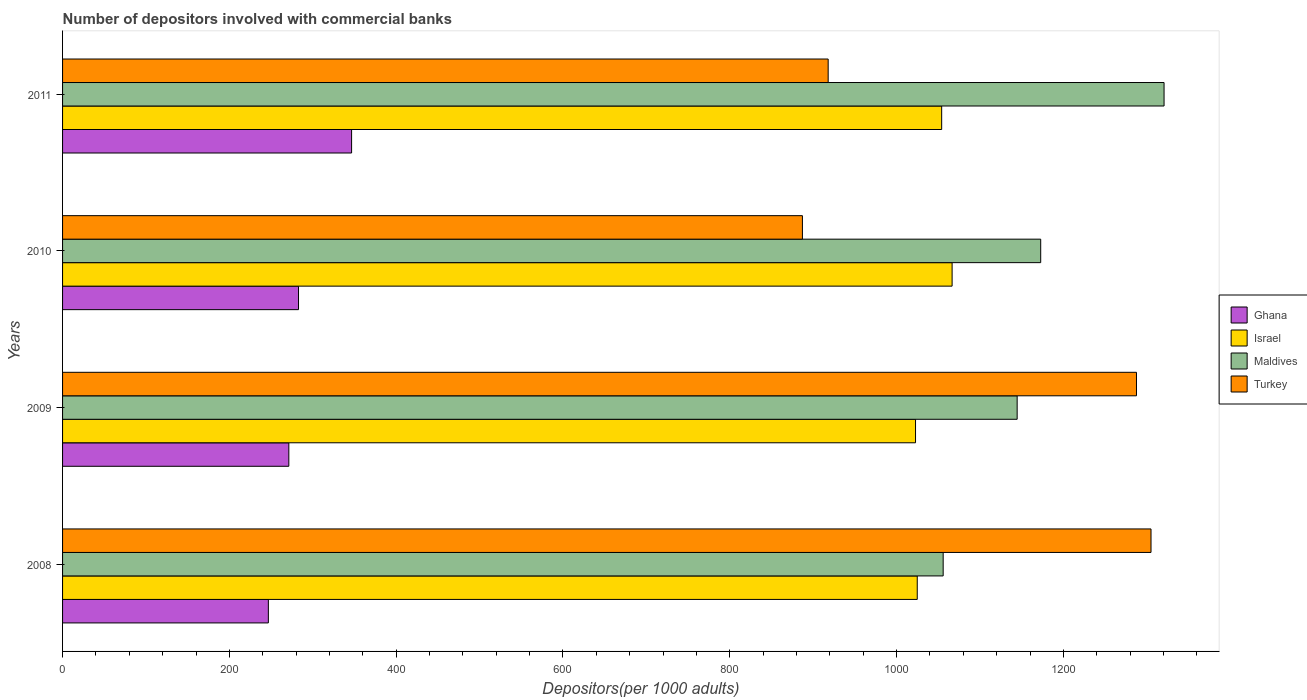How many different coloured bars are there?
Give a very brief answer. 4. Are the number of bars per tick equal to the number of legend labels?
Your answer should be very brief. Yes. Are the number of bars on each tick of the Y-axis equal?
Offer a terse response. Yes. What is the number of depositors involved with commercial banks in Turkey in 2011?
Offer a terse response. 917.97. Across all years, what is the maximum number of depositors involved with commercial banks in Maldives?
Make the answer very short. 1320.69. Across all years, what is the minimum number of depositors involved with commercial banks in Maldives?
Your answer should be compact. 1055.84. In which year was the number of depositors involved with commercial banks in Maldives maximum?
Your response must be concise. 2011. What is the total number of depositors involved with commercial banks in Ghana in the graph?
Give a very brief answer. 1147.49. What is the difference between the number of depositors involved with commercial banks in Ghana in 2008 and that in 2010?
Ensure brevity in your answer.  -36.17. What is the difference between the number of depositors involved with commercial banks in Maldives in 2010 and the number of depositors involved with commercial banks in Ghana in 2011?
Make the answer very short. 826.24. What is the average number of depositors involved with commercial banks in Maldives per year?
Give a very brief answer. 1173.47. In the year 2008, what is the difference between the number of depositors involved with commercial banks in Ghana and number of depositors involved with commercial banks in Maldives?
Offer a terse response. -809.09. In how many years, is the number of depositors involved with commercial banks in Ghana greater than 1080 ?
Offer a terse response. 0. What is the ratio of the number of depositors involved with commercial banks in Israel in 2008 to that in 2009?
Make the answer very short. 1. Is the number of depositors involved with commercial banks in Turkey in 2008 less than that in 2010?
Give a very brief answer. No. What is the difference between the highest and the second highest number of depositors involved with commercial banks in Ghana?
Your response must be concise. 63.63. What is the difference between the highest and the lowest number of depositors involved with commercial banks in Israel?
Ensure brevity in your answer.  43.86. Is it the case that in every year, the sum of the number of depositors involved with commercial banks in Maldives and number of depositors involved with commercial banks in Ghana is greater than the sum of number of depositors involved with commercial banks in Turkey and number of depositors involved with commercial banks in Israel?
Provide a short and direct response. No. What does the 4th bar from the top in 2011 represents?
Your response must be concise. Ghana. What does the 4th bar from the bottom in 2009 represents?
Provide a short and direct response. Turkey. How many bars are there?
Provide a short and direct response. 16. Are all the bars in the graph horizontal?
Your answer should be very brief. Yes. What is the difference between two consecutive major ticks on the X-axis?
Offer a very short reply. 200. Does the graph contain any zero values?
Provide a short and direct response. No. Does the graph contain grids?
Offer a very short reply. No. Where does the legend appear in the graph?
Keep it short and to the point. Center right. How are the legend labels stacked?
Offer a terse response. Vertical. What is the title of the graph?
Provide a succinct answer. Number of depositors involved with commercial banks. Does "Bhutan" appear as one of the legend labels in the graph?
Ensure brevity in your answer.  No. What is the label or title of the X-axis?
Offer a terse response. Depositors(per 1000 adults). What is the Depositors(per 1000 adults) in Ghana in 2008?
Make the answer very short. 246.75. What is the Depositors(per 1000 adults) of Israel in 2008?
Offer a terse response. 1024.76. What is the Depositors(per 1000 adults) in Maldives in 2008?
Keep it short and to the point. 1055.84. What is the Depositors(per 1000 adults) in Turkey in 2008?
Provide a short and direct response. 1305.04. What is the Depositors(per 1000 adults) in Ghana in 2009?
Ensure brevity in your answer.  271.28. What is the Depositors(per 1000 adults) of Israel in 2009?
Ensure brevity in your answer.  1022.7. What is the Depositors(per 1000 adults) in Maldives in 2009?
Make the answer very short. 1144.57. What is the Depositors(per 1000 adults) in Turkey in 2009?
Your answer should be compact. 1287.64. What is the Depositors(per 1000 adults) in Ghana in 2010?
Keep it short and to the point. 282.91. What is the Depositors(per 1000 adults) of Israel in 2010?
Your answer should be compact. 1066.56. What is the Depositors(per 1000 adults) in Maldives in 2010?
Provide a short and direct response. 1172.79. What is the Depositors(per 1000 adults) in Turkey in 2010?
Make the answer very short. 887.08. What is the Depositors(per 1000 adults) in Ghana in 2011?
Provide a succinct answer. 346.55. What is the Depositors(per 1000 adults) in Israel in 2011?
Provide a short and direct response. 1054.06. What is the Depositors(per 1000 adults) in Maldives in 2011?
Provide a succinct answer. 1320.69. What is the Depositors(per 1000 adults) in Turkey in 2011?
Make the answer very short. 917.97. Across all years, what is the maximum Depositors(per 1000 adults) in Ghana?
Offer a terse response. 346.55. Across all years, what is the maximum Depositors(per 1000 adults) of Israel?
Your answer should be compact. 1066.56. Across all years, what is the maximum Depositors(per 1000 adults) of Maldives?
Your answer should be very brief. 1320.69. Across all years, what is the maximum Depositors(per 1000 adults) of Turkey?
Your answer should be compact. 1305.04. Across all years, what is the minimum Depositors(per 1000 adults) of Ghana?
Your answer should be very brief. 246.75. Across all years, what is the minimum Depositors(per 1000 adults) of Israel?
Keep it short and to the point. 1022.7. Across all years, what is the minimum Depositors(per 1000 adults) in Maldives?
Your answer should be very brief. 1055.84. Across all years, what is the minimum Depositors(per 1000 adults) of Turkey?
Keep it short and to the point. 887.08. What is the total Depositors(per 1000 adults) of Ghana in the graph?
Offer a terse response. 1147.49. What is the total Depositors(per 1000 adults) of Israel in the graph?
Offer a terse response. 4168.08. What is the total Depositors(per 1000 adults) in Maldives in the graph?
Offer a terse response. 4693.88. What is the total Depositors(per 1000 adults) in Turkey in the graph?
Give a very brief answer. 4397.73. What is the difference between the Depositors(per 1000 adults) of Ghana in 2008 and that in 2009?
Give a very brief answer. -24.54. What is the difference between the Depositors(per 1000 adults) in Israel in 2008 and that in 2009?
Offer a terse response. 2.06. What is the difference between the Depositors(per 1000 adults) of Maldives in 2008 and that in 2009?
Ensure brevity in your answer.  -88.73. What is the difference between the Depositors(per 1000 adults) of Turkey in 2008 and that in 2009?
Offer a terse response. 17.41. What is the difference between the Depositors(per 1000 adults) of Ghana in 2008 and that in 2010?
Keep it short and to the point. -36.17. What is the difference between the Depositors(per 1000 adults) in Israel in 2008 and that in 2010?
Provide a short and direct response. -41.8. What is the difference between the Depositors(per 1000 adults) in Maldives in 2008 and that in 2010?
Offer a terse response. -116.95. What is the difference between the Depositors(per 1000 adults) of Turkey in 2008 and that in 2010?
Make the answer very short. 417.96. What is the difference between the Depositors(per 1000 adults) in Ghana in 2008 and that in 2011?
Offer a terse response. -99.8. What is the difference between the Depositors(per 1000 adults) of Israel in 2008 and that in 2011?
Ensure brevity in your answer.  -29.3. What is the difference between the Depositors(per 1000 adults) in Maldives in 2008 and that in 2011?
Provide a succinct answer. -264.85. What is the difference between the Depositors(per 1000 adults) of Turkey in 2008 and that in 2011?
Provide a short and direct response. 387.08. What is the difference between the Depositors(per 1000 adults) in Ghana in 2009 and that in 2010?
Provide a short and direct response. -11.63. What is the difference between the Depositors(per 1000 adults) of Israel in 2009 and that in 2010?
Provide a succinct answer. -43.86. What is the difference between the Depositors(per 1000 adults) in Maldives in 2009 and that in 2010?
Give a very brief answer. -28.22. What is the difference between the Depositors(per 1000 adults) of Turkey in 2009 and that in 2010?
Make the answer very short. 400.55. What is the difference between the Depositors(per 1000 adults) in Ghana in 2009 and that in 2011?
Give a very brief answer. -75.26. What is the difference between the Depositors(per 1000 adults) of Israel in 2009 and that in 2011?
Provide a short and direct response. -31.36. What is the difference between the Depositors(per 1000 adults) of Maldives in 2009 and that in 2011?
Your answer should be compact. -176.13. What is the difference between the Depositors(per 1000 adults) in Turkey in 2009 and that in 2011?
Provide a short and direct response. 369.67. What is the difference between the Depositors(per 1000 adults) of Ghana in 2010 and that in 2011?
Keep it short and to the point. -63.63. What is the difference between the Depositors(per 1000 adults) of Israel in 2010 and that in 2011?
Offer a terse response. 12.5. What is the difference between the Depositors(per 1000 adults) of Maldives in 2010 and that in 2011?
Give a very brief answer. -147.91. What is the difference between the Depositors(per 1000 adults) in Turkey in 2010 and that in 2011?
Your answer should be very brief. -30.88. What is the difference between the Depositors(per 1000 adults) of Ghana in 2008 and the Depositors(per 1000 adults) of Israel in 2009?
Ensure brevity in your answer.  -775.95. What is the difference between the Depositors(per 1000 adults) of Ghana in 2008 and the Depositors(per 1000 adults) of Maldives in 2009?
Your answer should be very brief. -897.82. What is the difference between the Depositors(per 1000 adults) of Ghana in 2008 and the Depositors(per 1000 adults) of Turkey in 2009?
Ensure brevity in your answer.  -1040.89. What is the difference between the Depositors(per 1000 adults) in Israel in 2008 and the Depositors(per 1000 adults) in Maldives in 2009?
Ensure brevity in your answer.  -119.8. What is the difference between the Depositors(per 1000 adults) of Israel in 2008 and the Depositors(per 1000 adults) of Turkey in 2009?
Offer a very short reply. -262.87. What is the difference between the Depositors(per 1000 adults) in Maldives in 2008 and the Depositors(per 1000 adults) in Turkey in 2009?
Make the answer very short. -231.8. What is the difference between the Depositors(per 1000 adults) of Ghana in 2008 and the Depositors(per 1000 adults) of Israel in 2010?
Make the answer very short. -819.82. What is the difference between the Depositors(per 1000 adults) of Ghana in 2008 and the Depositors(per 1000 adults) of Maldives in 2010?
Give a very brief answer. -926.04. What is the difference between the Depositors(per 1000 adults) in Ghana in 2008 and the Depositors(per 1000 adults) in Turkey in 2010?
Your response must be concise. -640.34. What is the difference between the Depositors(per 1000 adults) of Israel in 2008 and the Depositors(per 1000 adults) of Maldives in 2010?
Give a very brief answer. -148.02. What is the difference between the Depositors(per 1000 adults) in Israel in 2008 and the Depositors(per 1000 adults) in Turkey in 2010?
Make the answer very short. 137.68. What is the difference between the Depositors(per 1000 adults) in Maldives in 2008 and the Depositors(per 1000 adults) in Turkey in 2010?
Provide a succinct answer. 168.76. What is the difference between the Depositors(per 1000 adults) in Ghana in 2008 and the Depositors(per 1000 adults) in Israel in 2011?
Your answer should be very brief. -807.31. What is the difference between the Depositors(per 1000 adults) in Ghana in 2008 and the Depositors(per 1000 adults) in Maldives in 2011?
Give a very brief answer. -1073.95. What is the difference between the Depositors(per 1000 adults) of Ghana in 2008 and the Depositors(per 1000 adults) of Turkey in 2011?
Offer a terse response. -671.22. What is the difference between the Depositors(per 1000 adults) in Israel in 2008 and the Depositors(per 1000 adults) in Maldives in 2011?
Provide a succinct answer. -295.93. What is the difference between the Depositors(per 1000 adults) in Israel in 2008 and the Depositors(per 1000 adults) in Turkey in 2011?
Your response must be concise. 106.79. What is the difference between the Depositors(per 1000 adults) of Maldives in 2008 and the Depositors(per 1000 adults) of Turkey in 2011?
Make the answer very short. 137.87. What is the difference between the Depositors(per 1000 adults) of Ghana in 2009 and the Depositors(per 1000 adults) of Israel in 2010?
Your answer should be compact. -795.28. What is the difference between the Depositors(per 1000 adults) in Ghana in 2009 and the Depositors(per 1000 adults) in Maldives in 2010?
Your response must be concise. -901.5. What is the difference between the Depositors(per 1000 adults) of Ghana in 2009 and the Depositors(per 1000 adults) of Turkey in 2010?
Make the answer very short. -615.8. What is the difference between the Depositors(per 1000 adults) in Israel in 2009 and the Depositors(per 1000 adults) in Maldives in 2010?
Provide a succinct answer. -150.09. What is the difference between the Depositors(per 1000 adults) of Israel in 2009 and the Depositors(per 1000 adults) of Turkey in 2010?
Offer a very short reply. 135.62. What is the difference between the Depositors(per 1000 adults) in Maldives in 2009 and the Depositors(per 1000 adults) in Turkey in 2010?
Your answer should be compact. 257.48. What is the difference between the Depositors(per 1000 adults) of Ghana in 2009 and the Depositors(per 1000 adults) of Israel in 2011?
Offer a terse response. -782.77. What is the difference between the Depositors(per 1000 adults) in Ghana in 2009 and the Depositors(per 1000 adults) in Maldives in 2011?
Your answer should be compact. -1049.41. What is the difference between the Depositors(per 1000 adults) of Ghana in 2009 and the Depositors(per 1000 adults) of Turkey in 2011?
Provide a short and direct response. -646.68. What is the difference between the Depositors(per 1000 adults) of Israel in 2009 and the Depositors(per 1000 adults) of Maldives in 2011?
Your answer should be very brief. -297.99. What is the difference between the Depositors(per 1000 adults) of Israel in 2009 and the Depositors(per 1000 adults) of Turkey in 2011?
Your answer should be compact. 104.73. What is the difference between the Depositors(per 1000 adults) in Maldives in 2009 and the Depositors(per 1000 adults) in Turkey in 2011?
Provide a succinct answer. 226.6. What is the difference between the Depositors(per 1000 adults) of Ghana in 2010 and the Depositors(per 1000 adults) of Israel in 2011?
Ensure brevity in your answer.  -771.15. What is the difference between the Depositors(per 1000 adults) of Ghana in 2010 and the Depositors(per 1000 adults) of Maldives in 2011?
Ensure brevity in your answer.  -1037.78. What is the difference between the Depositors(per 1000 adults) of Ghana in 2010 and the Depositors(per 1000 adults) of Turkey in 2011?
Provide a short and direct response. -635.05. What is the difference between the Depositors(per 1000 adults) of Israel in 2010 and the Depositors(per 1000 adults) of Maldives in 2011?
Provide a succinct answer. -254.13. What is the difference between the Depositors(per 1000 adults) of Israel in 2010 and the Depositors(per 1000 adults) of Turkey in 2011?
Provide a succinct answer. 148.59. What is the difference between the Depositors(per 1000 adults) in Maldives in 2010 and the Depositors(per 1000 adults) in Turkey in 2011?
Provide a succinct answer. 254.82. What is the average Depositors(per 1000 adults) of Ghana per year?
Your response must be concise. 286.87. What is the average Depositors(per 1000 adults) of Israel per year?
Your answer should be compact. 1042.02. What is the average Depositors(per 1000 adults) in Maldives per year?
Provide a short and direct response. 1173.47. What is the average Depositors(per 1000 adults) of Turkey per year?
Offer a very short reply. 1099.43. In the year 2008, what is the difference between the Depositors(per 1000 adults) in Ghana and Depositors(per 1000 adults) in Israel?
Ensure brevity in your answer.  -778.02. In the year 2008, what is the difference between the Depositors(per 1000 adults) in Ghana and Depositors(per 1000 adults) in Maldives?
Your answer should be very brief. -809.09. In the year 2008, what is the difference between the Depositors(per 1000 adults) in Ghana and Depositors(per 1000 adults) in Turkey?
Provide a short and direct response. -1058.3. In the year 2008, what is the difference between the Depositors(per 1000 adults) of Israel and Depositors(per 1000 adults) of Maldives?
Your answer should be compact. -31.08. In the year 2008, what is the difference between the Depositors(per 1000 adults) in Israel and Depositors(per 1000 adults) in Turkey?
Provide a short and direct response. -280.28. In the year 2008, what is the difference between the Depositors(per 1000 adults) of Maldives and Depositors(per 1000 adults) of Turkey?
Make the answer very short. -249.2. In the year 2009, what is the difference between the Depositors(per 1000 adults) in Ghana and Depositors(per 1000 adults) in Israel?
Offer a very short reply. -751.42. In the year 2009, what is the difference between the Depositors(per 1000 adults) in Ghana and Depositors(per 1000 adults) in Maldives?
Offer a terse response. -873.28. In the year 2009, what is the difference between the Depositors(per 1000 adults) of Ghana and Depositors(per 1000 adults) of Turkey?
Ensure brevity in your answer.  -1016.35. In the year 2009, what is the difference between the Depositors(per 1000 adults) of Israel and Depositors(per 1000 adults) of Maldives?
Offer a terse response. -121.86. In the year 2009, what is the difference between the Depositors(per 1000 adults) of Israel and Depositors(per 1000 adults) of Turkey?
Make the answer very short. -264.94. In the year 2009, what is the difference between the Depositors(per 1000 adults) of Maldives and Depositors(per 1000 adults) of Turkey?
Offer a very short reply. -143.07. In the year 2010, what is the difference between the Depositors(per 1000 adults) in Ghana and Depositors(per 1000 adults) in Israel?
Offer a terse response. -783.65. In the year 2010, what is the difference between the Depositors(per 1000 adults) of Ghana and Depositors(per 1000 adults) of Maldives?
Provide a short and direct response. -889.87. In the year 2010, what is the difference between the Depositors(per 1000 adults) in Ghana and Depositors(per 1000 adults) in Turkey?
Your response must be concise. -604.17. In the year 2010, what is the difference between the Depositors(per 1000 adults) in Israel and Depositors(per 1000 adults) in Maldives?
Provide a succinct answer. -106.22. In the year 2010, what is the difference between the Depositors(per 1000 adults) of Israel and Depositors(per 1000 adults) of Turkey?
Provide a succinct answer. 179.48. In the year 2010, what is the difference between the Depositors(per 1000 adults) in Maldives and Depositors(per 1000 adults) in Turkey?
Make the answer very short. 285.7. In the year 2011, what is the difference between the Depositors(per 1000 adults) of Ghana and Depositors(per 1000 adults) of Israel?
Offer a very short reply. -707.51. In the year 2011, what is the difference between the Depositors(per 1000 adults) of Ghana and Depositors(per 1000 adults) of Maldives?
Provide a succinct answer. -974.15. In the year 2011, what is the difference between the Depositors(per 1000 adults) of Ghana and Depositors(per 1000 adults) of Turkey?
Provide a succinct answer. -571.42. In the year 2011, what is the difference between the Depositors(per 1000 adults) in Israel and Depositors(per 1000 adults) in Maldives?
Offer a very short reply. -266.63. In the year 2011, what is the difference between the Depositors(per 1000 adults) of Israel and Depositors(per 1000 adults) of Turkey?
Offer a very short reply. 136.09. In the year 2011, what is the difference between the Depositors(per 1000 adults) of Maldives and Depositors(per 1000 adults) of Turkey?
Provide a short and direct response. 402.72. What is the ratio of the Depositors(per 1000 adults) of Ghana in 2008 to that in 2009?
Give a very brief answer. 0.91. What is the ratio of the Depositors(per 1000 adults) of Israel in 2008 to that in 2009?
Ensure brevity in your answer.  1. What is the ratio of the Depositors(per 1000 adults) of Maldives in 2008 to that in 2009?
Give a very brief answer. 0.92. What is the ratio of the Depositors(per 1000 adults) of Turkey in 2008 to that in 2009?
Make the answer very short. 1.01. What is the ratio of the Depositors(per 1000 adults) of Ghana in 2008 to that in 2010?
Your response must be concise. 0.87. What is the ratio of the Depositors(per 1000 adults) in Israel in 2008 to that in 2010?
Offer a very short reply. 0.96. What is the ratio of the Depositors(per 1000 adults) in Maldives in 2008 to that in 2010?
Your response must be concise. 0.9. What is the ratio of the Depositors(per 1000 adults) in Turkey in 2008 to that in 2010?
Your answer should be compact. 1.47. What is the ratio of the Depositors(per 1000 adults) in Ghana in 2008 to that in 2011?
Make the answer very short. 0.71. What is the ratio of the Depositors(per 1000 adults) of Israel in 2008 to that in 2011?
Give a very brief answer. 0.97. What is the ratio of the Depositors(per 1000 adults) of Maldives in 2008 to that in 2011?
Give a very brief answer. 0.8. What is the ratio of the Depositors(per 1000 adults) of Turkey in 2008 to that in 2011?
Ensure brevity in your answer.  1.42. What is the ratio of the Depositors(per 1000 adults) of Ghana in 2009 to that in 2010?
Your response must be concise. 0.96. What is the ratio of the Depositors(per 1000 adults) in Israel in 2009 to that in 2010?
Provide a succinct answer. 0.96. What is the ratio of the Depositors(per 1000 adults) of Maldives in 2009 to that in 2010?
Your answer should be very brief. 0.98. What is the ratio of the Depositors(per 1000 adults) in Turkey in 2009 to that in 2010?
Your answer should be compact. 1.45. What is the ratio of the Depositors(per 1000 adults) of Ghana in 2009 to that in 2011?
Ensure brevity in your answer.  0.78. What is the ratio of the Depositors(per 1000 adults) in Israel in 2009 to that in 2011?
Offer a very short reply. 0.97. What is the ratio of the Depositors(per 1000 adults) in Maldives in 2009 to that in 2011?
Offer a terse response. 0.87. What is the ratio of the Depositors(per 1000 adults) in Turkey in 2009 to that in 2011?
Provide a succinct answer. 1.4. What is the ratio of the Depositors(per 1000 adults) in Ghana in 2010 to that in 2011?
Your response must be concise. 0.82. What is the ratio of the Depositors(per 1000 adults) in Israel in 2010 to that in 2011?
Give a very brief answer. 1.01. What is the ratio of the Depositors(per 1000 adults) in Maldives in 2010 to that in 2011?
Ensure brevity in your answer.  0.89. What is the ratio of the Depositors(per 1000 adults) in Turkey in 2010 to that in 2011?
Your response must be concise. 0.97. What is the difference between the highest and the second highest Depositors(per 1000 adults) of Ghana?
Your answer should be compact. 63.63. What is the difference between the highest and the second highest Depositors(per 1000 adults) in Israel?
Your answer should be compact. 12.5. What is the difference between the highest and the second highest Depositors(per 1000 adults) of Maldives?
Give a very brief answer. 147.91. What is the difference between the highest and the second highest Depositors(per 1000 adults) of Turkey?
Offer a terse response. 17.41. What is the difference between the highest and the lowest Depositors(per 1000 adults) of Ghana?
Provide a succinct answer. 99.8. What is the difference between the highest and the lowest Depositors(per 1000 adults) of Israel?
Keep it short and to the point. 43.86. What is the difference between the highest and the lowest Depositors(per 1000 adults) of Maldives?
Provide a succinct answer. 264.85. What is the difference between the highest and the lowest Depositors(per 1000 adults) of Turkey?
Offer a very short reply. 417.96. 